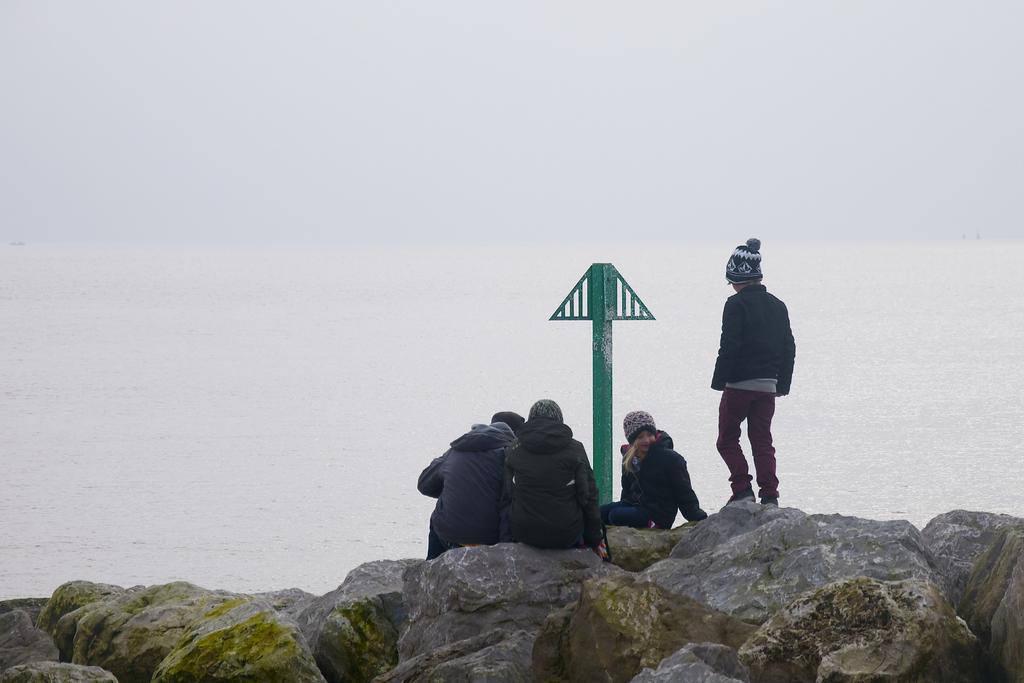Please provide a concise description of this image. In this image there are three persons sitting on the rocks and there is also one person standing. Image also consists of green color pole. In the background there is river. 